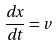Convert formula to latex. <formula><loc_0><loc_0><loc_500><loc_500>\frac { d x } { d t } = v</formula> 